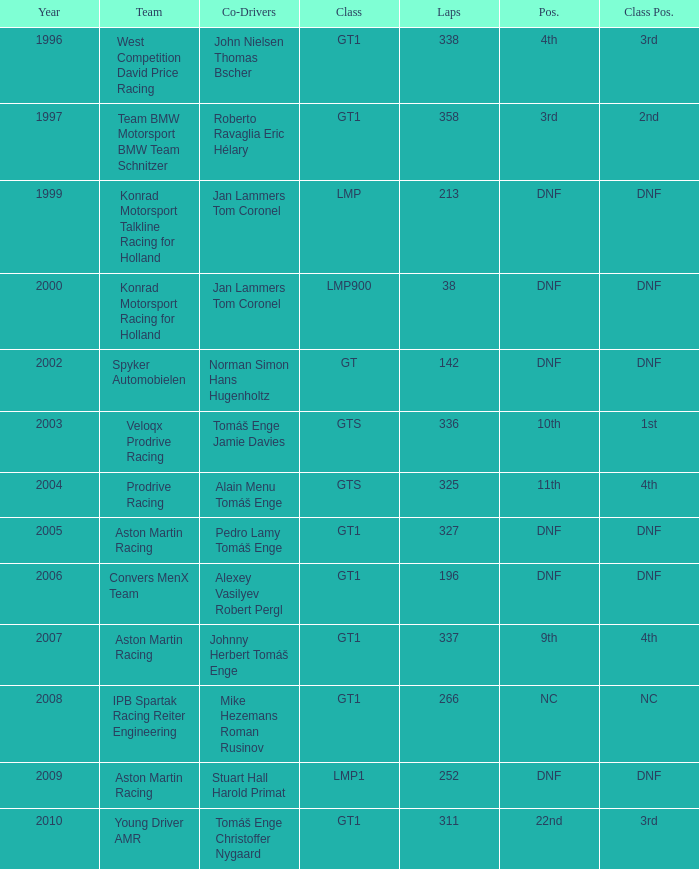In which class had 252 laps and a position of dnf? LMP1. Would you be able to parse every entry in this table? {'header': ['Year', 'Team', 'Co-Drivers', 'Class', 'Laps', 'Pos.', 'Class Pos.'], 'rows': [['1996', 'West Competition David Price Racing', 'John Nielsen Thomas Bscher', 'GT1', '338', '4th', '3rd'], ['1997', 'Team BMW Motorsport BMW Team Schnitzer', 'Roberto Ravaglia Eric Hélary', 'GT1', '358', '3rd', '2nd'], ['1999', 'Konrad Motorsport Talkline Racing for Holland', 'Jan Lammers Tom Coronel', 'LMP', '213', 'DNF', 'DNF'], ['2000', 'Konrad Motorsport Racing for Holland', 'Jan Lammers Tom Coronel', 'LMP900', '38', 'DNF', 'DNF'], ['2002', 'Spyker Automobielen', 'Norman Simon Hans Hugenholtz', 'GT', '142', 'DNF', 'DNF'], ['2003', 'Veloqx Prodrive Racing', 'Tomáš Enge Jamie Davies', 'GTS', '336', '10th', '1st'], ['2004', 'Prodrive Racing', 'Alain Menu Tomáš Enge', 'GTS', '325', '11th', '4th'], ['2005', 'Aston Martin Racing', 'Pedro Lamy Tomáš Enge', 'GT1', '327', 'DNF', 'DNF'], ['2006', 'Convers MenX Team', 'Alexey Vasilyev Robert Pergl', 'GT1', '196', 'DNF', 'DNF'], ['2007', 'Aston Martin Racing', 'Johnny Herbert Tomáš Enge', 'GT1', '337', '9th', '4th'], ['2008', 'IPB Spartak Racing Reiter Engineering', 'Mike Hezemans Roman Rusinov', 'GT1', '266', 'NC', 'NC'], ['2009', 'Aston Martin Racing', 'Stuart Hall Harold Primat', 'LMP1', '252', 'DNF', 'DNF'], ['2010', 'Young Driver AMR', 'Tomáš Enge Christoffer Nygaard', 'GT1', '311', '22nd', '3rd']]} 